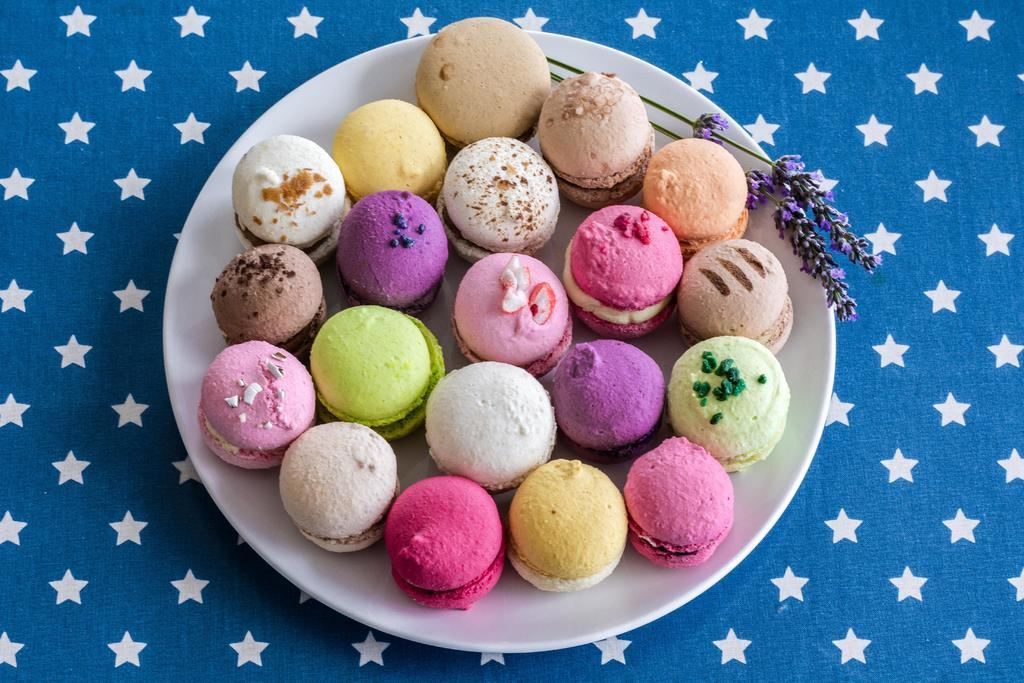What type of food is on the plate in the image? There are cookies on a plate in the image. What is the plate placed on? The plate is placed on a cloth. Can you describe the design of the cloth? The cloth has a stars design. What type of coach is visible in the image? There is no coach present in the image. What type of vase is placed on the cloth in the image? There is no vase present in the image. 